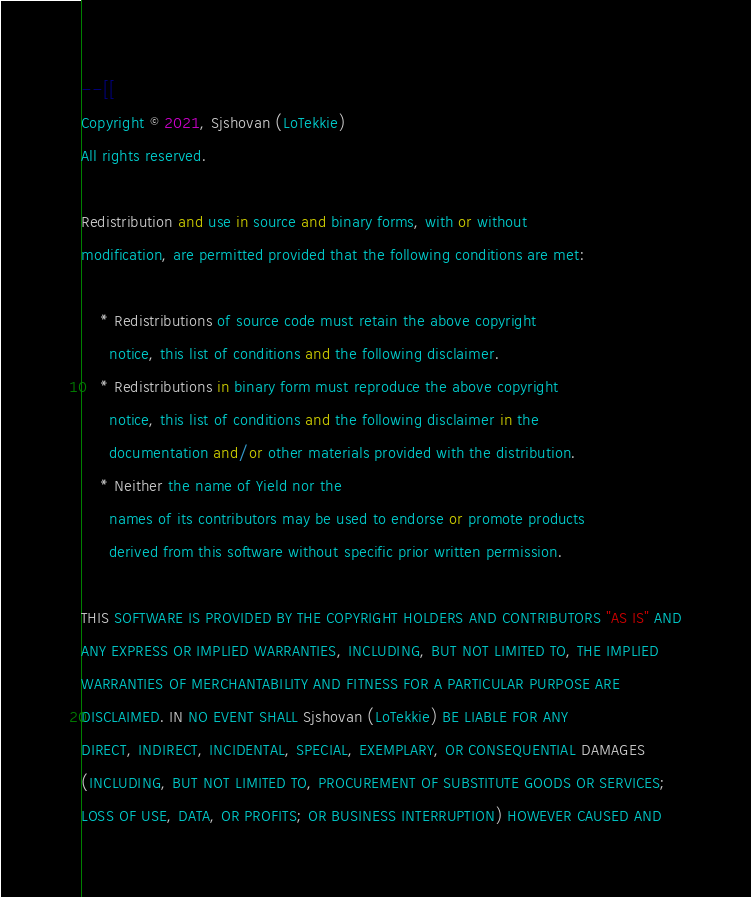<code> <loc_0><loc_0><loc_500><loc_500><_Lua_>--[[
Copyright © 2021, Sjshovan (LoTekkie)
All rights reserved.

Redistribution and use in source and binary forms, with or without
modification, are permitted provided that the following conditions are met:

    * Redistributions of source code must retain the above copyright
      notice, this list of conditions and the following disclaimer.
    * Redistributions in binary form must reproduce the above copyright
      notice, this list of conditions and the following disclaimer in the
      documentation and/or other materials provided with the distribution.
    * Neither the name of Yield nor the
      names of its contributors may be used to endorse or promote products
      derived from this software without specific prior written permission.

THIS SOFTWARE IS PROVIDED BY THE COPYRIGHT HOLDERS AND CONTRIBUTORS "AS IS" AND
ANY EXPRESS OR IMPLIED WARRANTIES, INCLUDING, BUT NOT LIMITED TO, THE IMPLIED
WARRANTIES OF MERCHANTABILITY AND FITNESS FOR A PARTICULAR PURPOSE ARE
DISCLAIMED. IN NO EVENT SHALL Sjshovan (LoTekkie) BE LIABLE FOR ANY
DIRECT, INDIRECT, INCIDENTAL, SPECIAL, EXEMPLARY, OR CONSEQUENTIAL DAMAGES
(INCLUDING, BUT NOT LIMITED TO, PROCUREMENT OF SUBSTITUTE GOODS OR SERVICES;
LOSS OF USE, DATA, OR PROFITS; OR BUSINESS INTERRUPTION) HOWEVER CAUSED AND</code> 